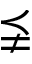<formula> <loc_0><loc_0><loc_500><loc_500>\precneqq</formula> 